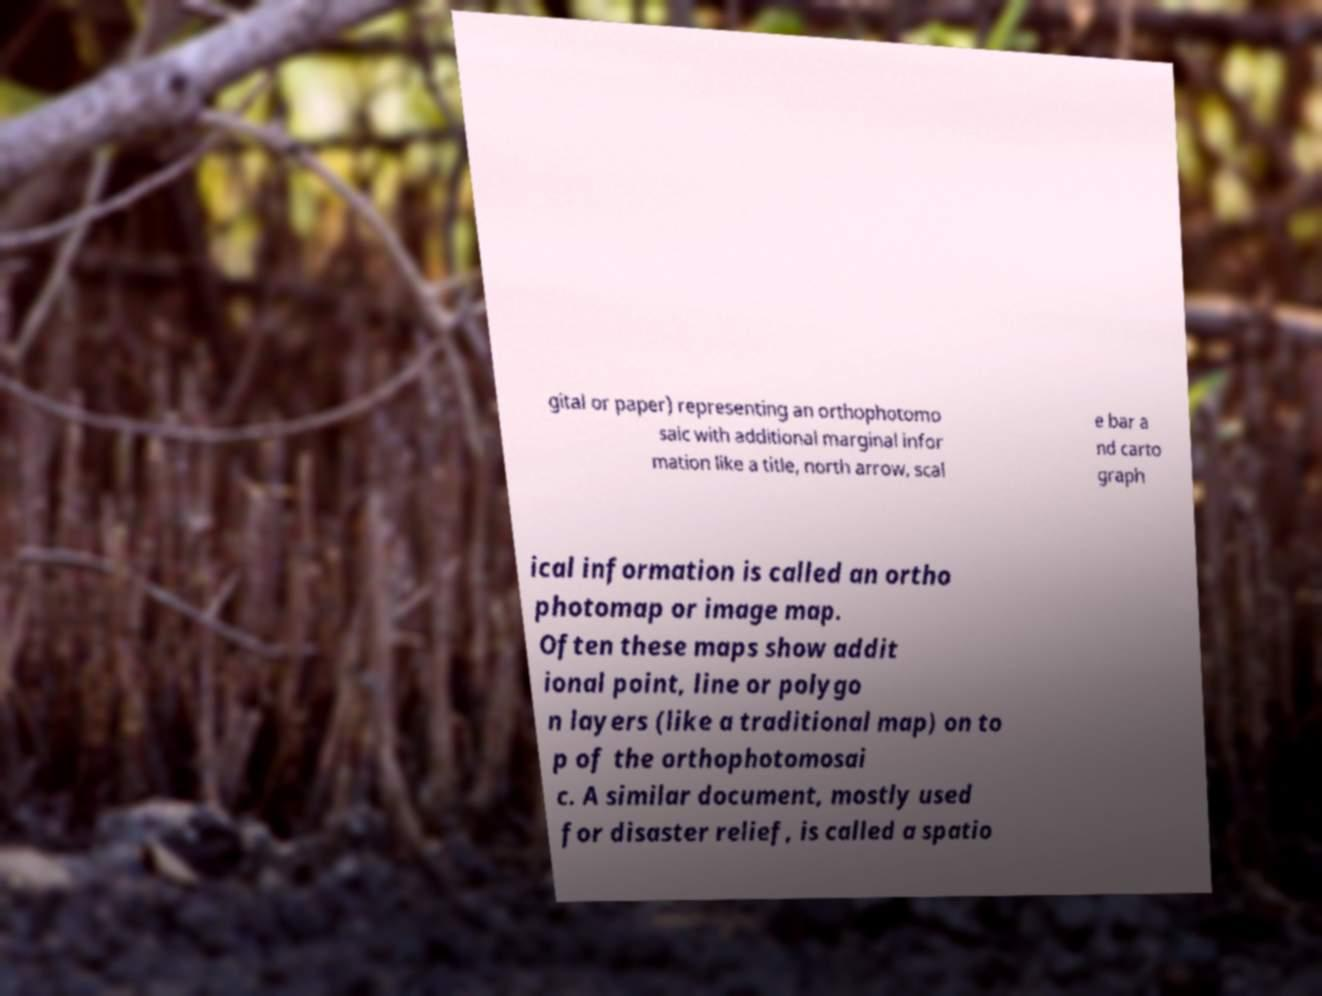Could you assist in decoding the text presented in this image and type it out clearly? gital or paper) representing an orthophotomo saic with additional marginal infor mation like a title, north arrow, scal e bar a nd carto graph ical information is called an ortho photomap or image map. Often these maps show addit ional point, line or polygo n layers (like a traditional map) on to p of the orthophotomosai c. A similar document, mostly used for disaster relief, is called a spatio 